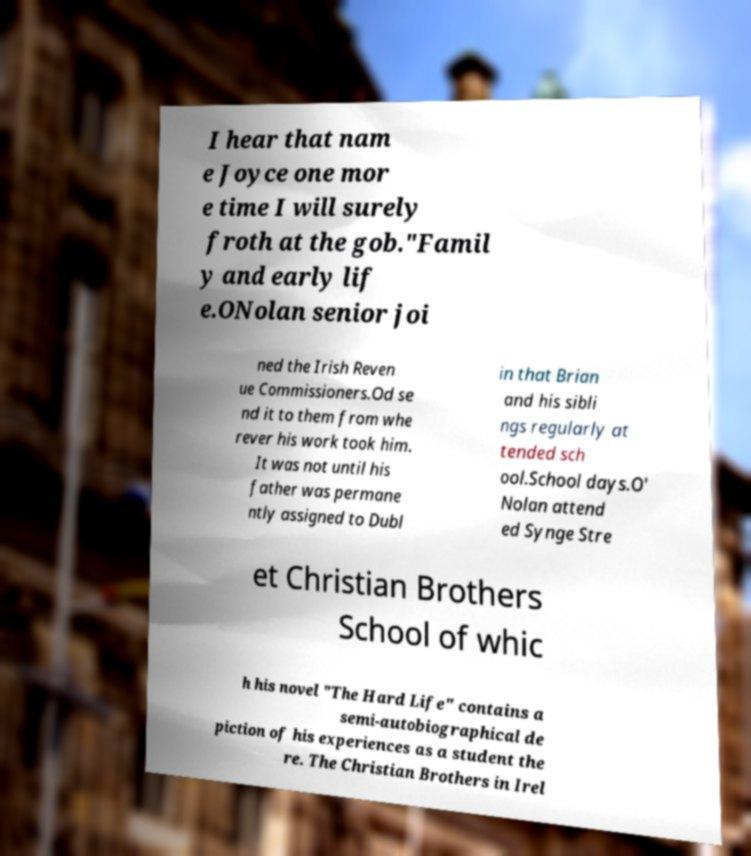Could you assist in decoding the text presented in this image and type it out clearly? I hear that nam e Joyce one mor e time I will surely froth at the gob."Famil y and early lif e.ONolan senior joi ned the Irish Reven ue Commissioners.Od se nd it to them from whe rever his work took him. It was not until his father was permane ntly assigned to Dubl in that Brian and his sibli ngs regularly at tended sch ool.School days.O' Nolan attend ed Synge Stre et Christian Brothers School of whic h his novel "The Hard Life" contains a semi-autobiographical de piction of his experiences as a student the re. The Christian Brothers in Irel 